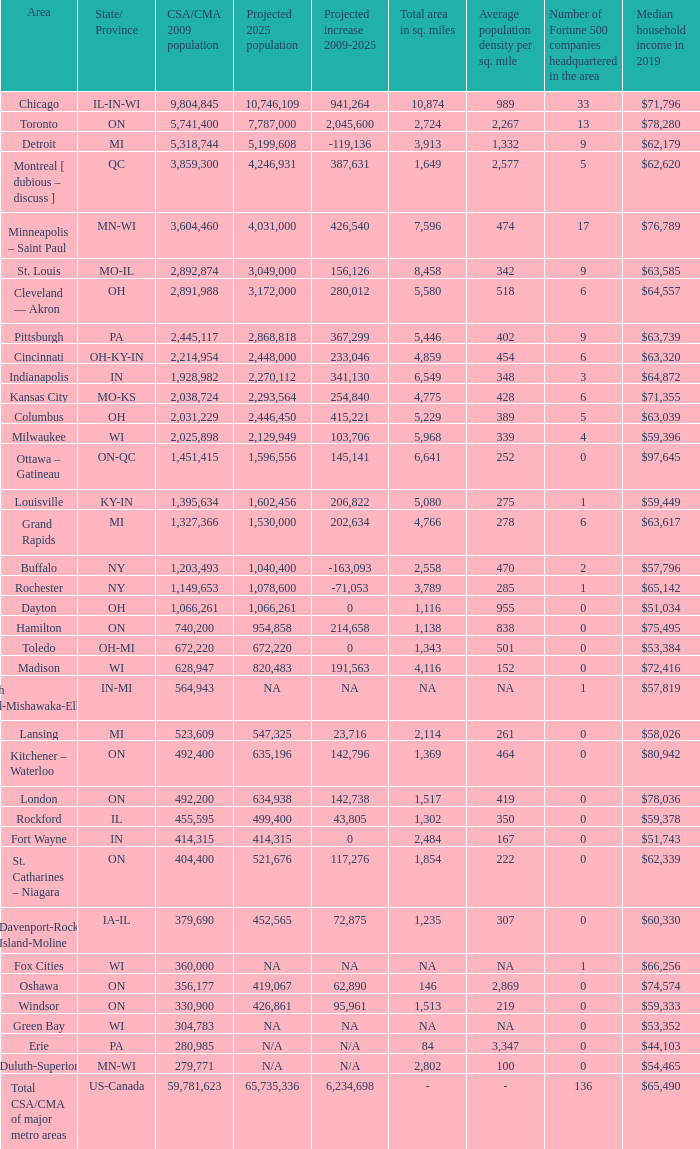What's the CSA/CMA Population in IA-IL? 379690.0. 